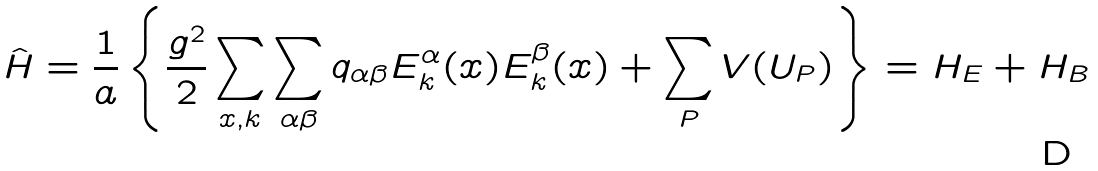Convert formula to latex. <formula><loc_0><loc_0><loc_500><loc_500>\hat { H } = \frac { 1 } { a } \left \{ \frac { g ^ { 2 } } { 2 } \sum _ { x , k } \sum _ { \alpha \beta } q _ { \alpha \beta } E ^ { \alpha } _ { k } ( x ) E ^ { \beta } _ { k } ( x ) + \sum _ { P } V ( U _ { P } ) \right \} = H _ { E } + H _ { B }</formula> 